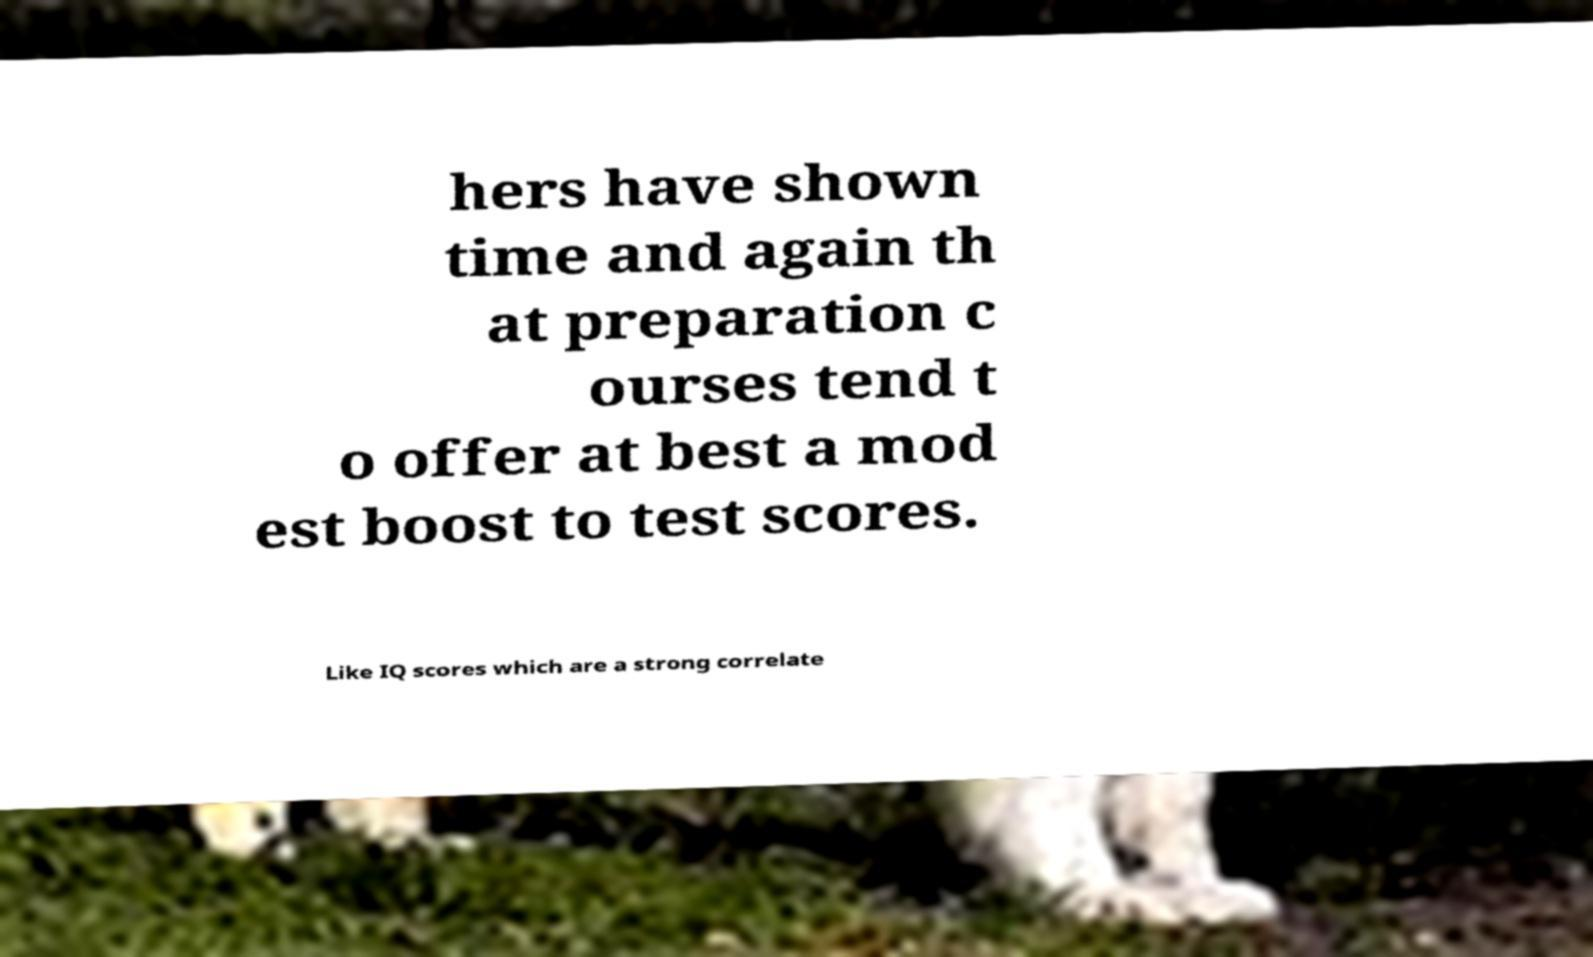Please identify and transcribe the text found in this image. hers have shown time and again th at preparation c ourses tend t o offer at best a mod est boost to test scores. Like IQ scores which are a strong correlate 